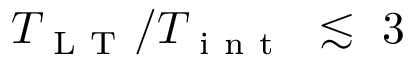Convert formula to latex. <formula><loc_0><loc_0><loc_500><loc_500>T _ { L T } / T _ { i n t } \lesssim 3</formula> 